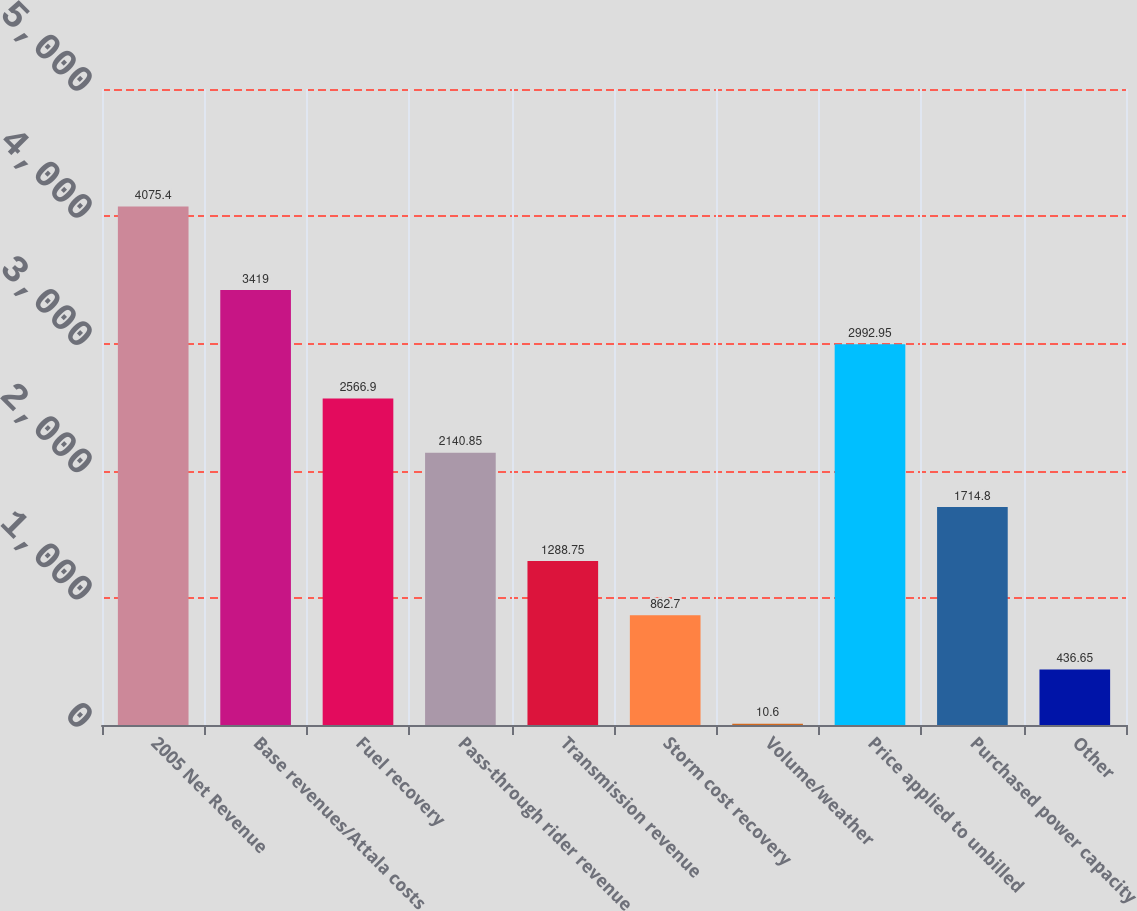Convert chart. <chart><loc_0><loc_0><loc_500><loc_500><bar_chart><fcel>2005 Net Revenue<fcel>Base revenues/Attala costs<fcel>Fuel recovery<fcel>Pass-through rider revenue<fcel>Transmission revenue<fcel>Storm cost recovery<fcel>Volume/weather<fcel>Price applied to unbilled<fcel>Purchased power capacity<fcel>Other<nl><fcel>4075.4<fcel>3419<fcel>2566.9<fcel>2140.85<fcel>1288.75<fcel>862.7<fcel>10.6<fcel>2992.95<fcel>1714.8<fcel>436.65<nl></chart> 